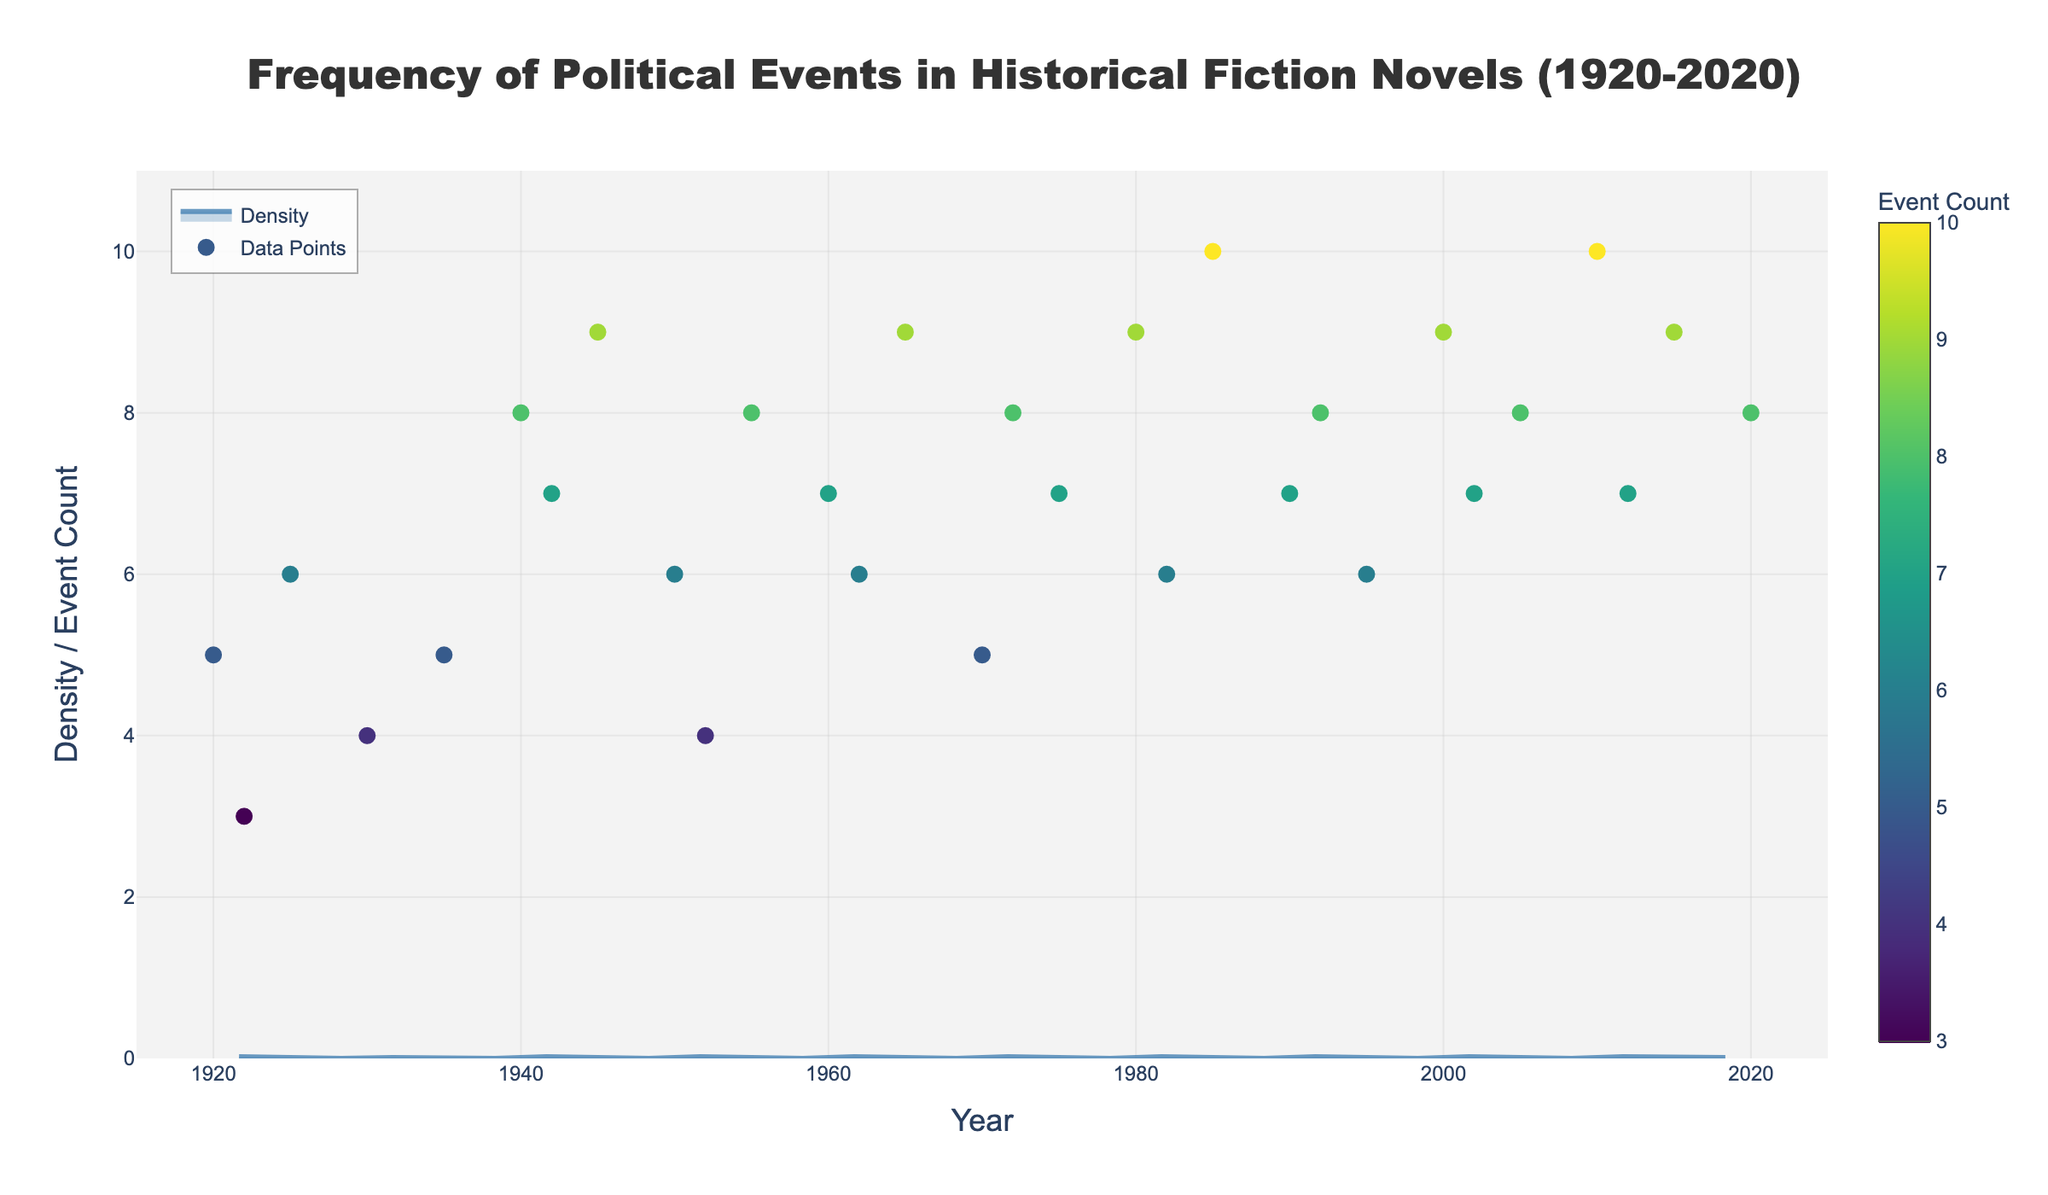What's the title of the figure? The title of the figure is displayed at the top of the graph. It summarizes what the data visualization is about.
Answer: Frequency of Political Events in Historical Fiction Novels (1920-2020) What is the time range covered by the data in the plot? The x-axis represents the time range from the minimum to the maximum year displayed in the plot.
Answer: 1920 to 2020 Which decade shows the highest number of political events in historical fiction novels? By observing the scatter plot and identifying the decade with the most frequent high event counts, we can determine this.
Answer: 2010s How many novels have political event counts of 9 or higher? Count the data points in the scatter plot that are at or above 9 on the y-axis.
Answer: 8 novels Which year had the highest political event count and what was it? Find the data point in the scatter plot which is the highest on the y-axis and note the corresponding year and event count.
Answer: 2010, with 10 events How do the political event counts in the 1940s compare to the 1980s? Compare the y-axis values of the data points in the 1940s to those in the 1980s to see which decade had higher counts more often.
Answer: 1940s are generally higher What's the average number of political events per novel in the 1950s? Sum the political event counts for the 1950s and divide by the total number of novels in that decade. (6 + 4 + 8 = 18, and there are 3 novels, so 18/3)
Answer: 6 During which period do we observe the lowest density of political events? Identify where the density curve (filled area) dips the lowest across the x-axis (years).
Answer: Around the 1930s Is there a trend in the number of political events from 1920 to 2020? Look at the scatter plot to determine if there is an increasing, decreasing, or no clear trend in the number of political events over time.
Answer: Increasing trend How does the density plot visually represent periods with a high frequency of political events? Explain how the density curve's height and color might indicate periods with higher event frequencies.
Answer: Peaks in the density plot represent periods with high frequencies 